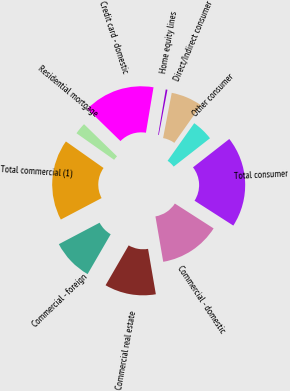<chart> <loc_0><loc_0><loc_500><loc_500><pie_chart><fcel>Residential mortgage<fcel>Credit card - domestic<fcel>Home equity lines<fcel>Direct/Indirect consumer<fcel>Other consumer<fcel>Total consumer<fcel>Commercial - domestic<fcel>Commercial real estate<fcel>Commercial - foreign<fcel>Total commercial (1)<nl><fcel>2.51%<fcel>15.35%<fcel>0.37%<fcel>6.79%<fcel>4.65%<fcel>19.63%<fcel>13.21%<fcel>11.07%<fcel>8.93%<fcel>17.49%<nl></chart> 